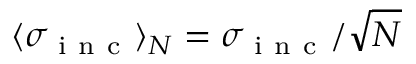Convert formula to latex. <formula><loc_0><loc_0><loc_500><loc_500>\langle \sigma _ { i n c } \rangle _ { N } = \sigma _ { i n c } / \sqrt { N }</formula> 